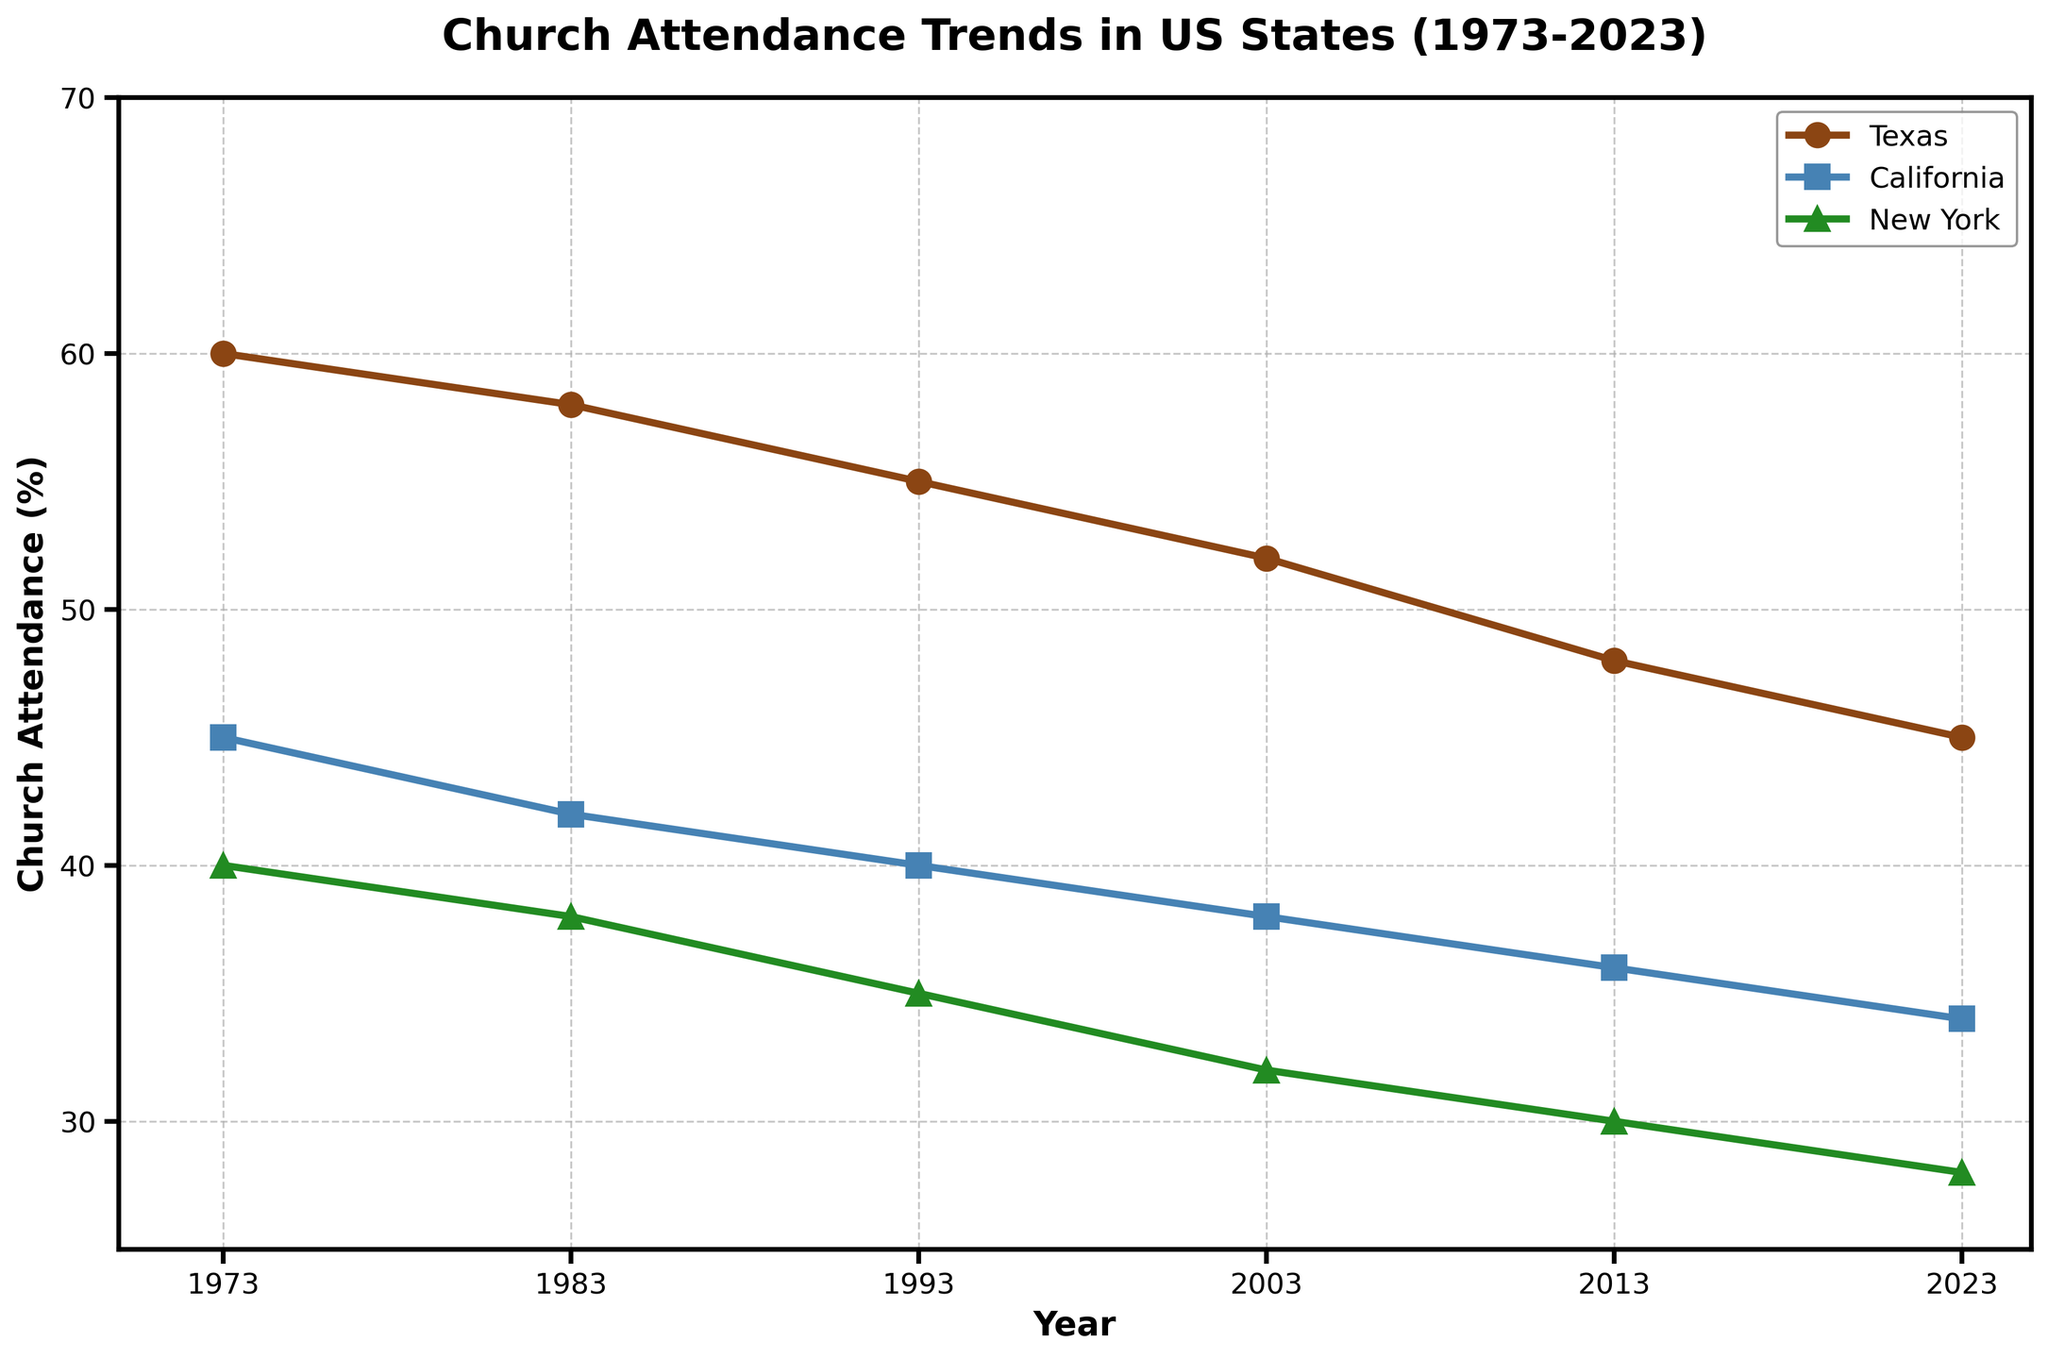What is the title of the plot? The title is usually displayed at the top of the plot, summarizing the figure in one line. It reads 'Church Attendance Trends in US States (1973-2023)'.
Answer: Church Attendance Trends in US States (1973-2023) Which state had the highest percentage of church attendance in 1973? The plot's lines and markers help us identify this. In 1973, the plot for Texas starts at 60%, which is the highest compared to the other states.
Answer: Texas Describe the trend of church attendance in New York over the 50-year period. By following the line for New York from 1973 to 2023, the attendance decreases from 40% to 28%, showing a clear downward trend.
Answer: Decreasing How many years are indicated on the x-axis? Looking at the x-axis ticks, we see that the years are marked every 10 years from 1973 to 2023. That gives 6 different years displayed.
Answer: 6 By how much has church attendance in California decreased from 1973 to 2023? In 1973, California had 45% attendance and in 2023, it had 34%. The decrease is 45% - 34% = 11%.
Answer: 11% Which state had the smallest decline in church attendance over the 50 years? Comparing the lines, Texas decreased from 60% to 45% (15%), California from 45% to 34% (11%), and New York from 40% to 28% (12%). California had the smallest decline.
Answer: California What is the average church attendance for Texas over the plotted years? Texas's percentages are 60, 58, 55, 52, 48, and 45. The average is (60 + 58 + 55 + 52 + 48 + 45)/6, which equals 53%.
Answer: 53% In what year did California’s church attendance fall below 40% for the first time? By tracing California's line, it falls below 40% between 1993 and 2003. In 2003, it is clearly 38%.
Answer: 2003 What percentage of church attendance did New York have in 2013? Following the line for New York to the year 2013, the percentage is 30%.
Answer: 30% Which state had the highest percentage decrease in church attendance from 1973 to 2023? Texas: 60% to 45% (15% decrease), California: 45% to 34% (11% decrease), New York: 40% to 28% (12% decrease). Texas had the highest decrease.
Answer: Texas 